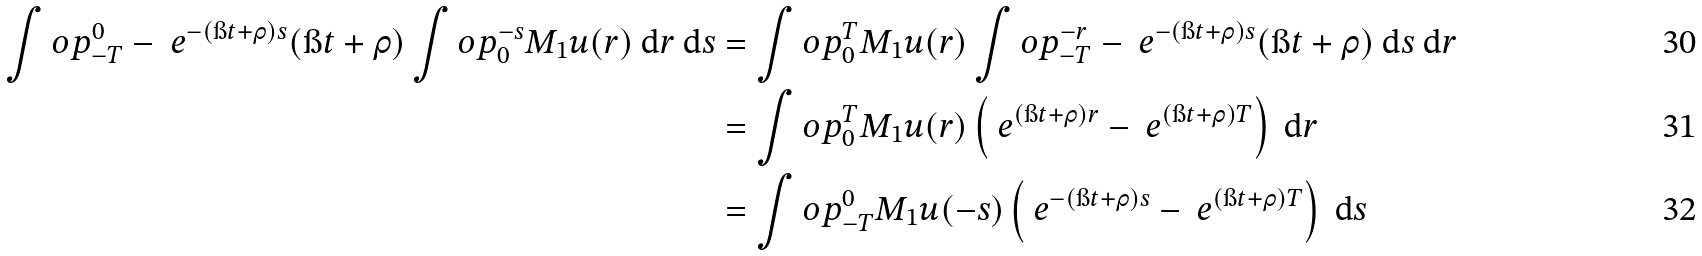<formula> <loc_0><loc_0><loc_500><loc_500>\int o p _ { - T } ^ { 0 } - \ e ^ { - ( \i t + \rho ) s } ( \i t + \rho ) \int o p _ { 0 } ^ { - s } M _ { 1 } u ( r ) \text { d} r \text { d} s & = \int o p _ { 0 } ^ { T } M _ { 1 } u ( r ) \int o p _ { - T } ^ { - r } - \ e ^ { - ( \i t + \rho ) s } ( \i t + \rho ) \text { d} s \text { d} r \\ & = \int o p _ { 0 } ^ { T } M _ { 1 } u ( r ) \left ( \ e ^ { ( \i t + \rho ) r } - \ e ^ { ( \i t + \rho ) T } \right ) \text { d} r \\ & = \int o p _ { - T } ^ { 0 } M _ { 1 } u ( - s ) \left ( \ e ^ { - ( \i t + \rho ) s } - \ e ^ { ( \i t + \rho ) T } \right ) \text { d} s</formula> 